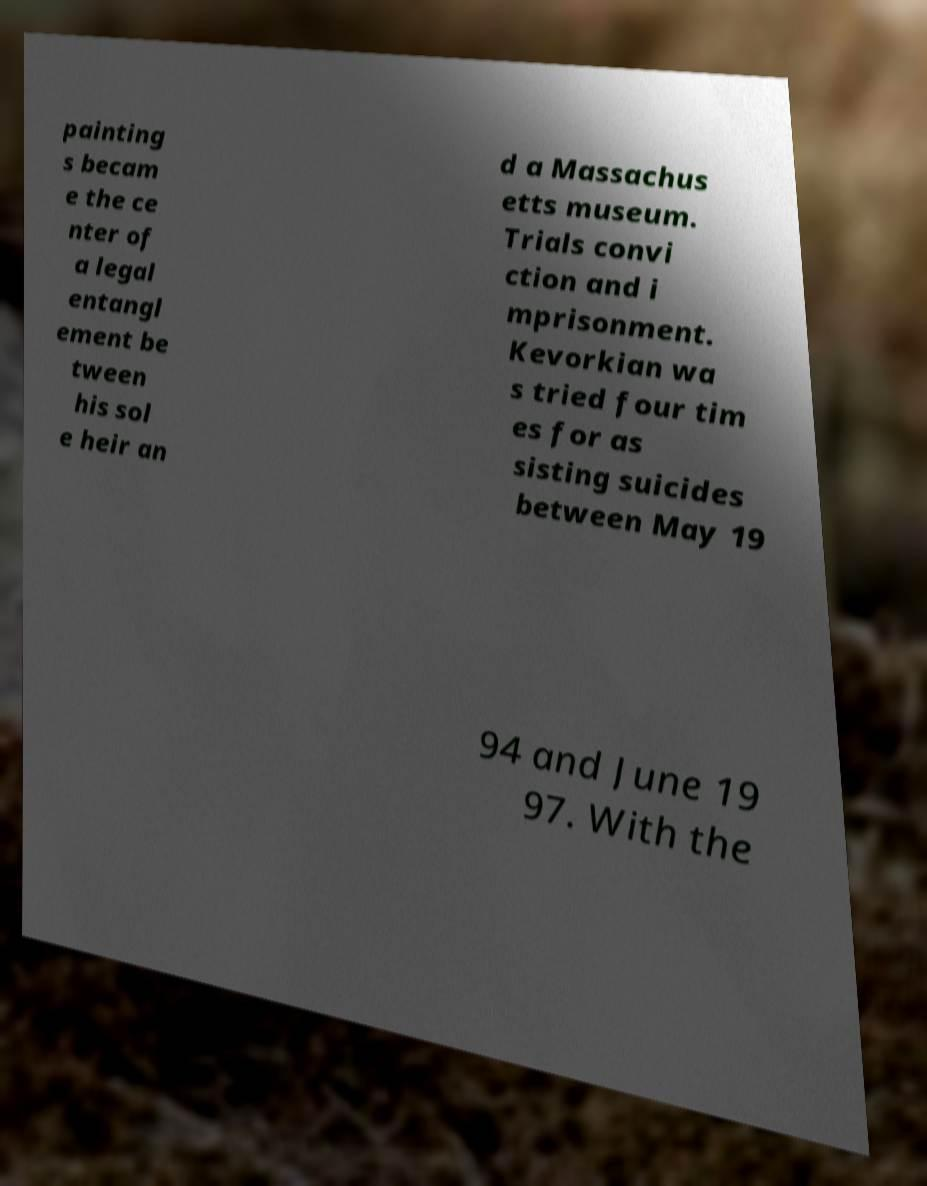There's text embedded in this image that I need extracted. Can you transcribe it verbatim? painting s becam e the ce nter of a legal entangl ement be tween his sol e heir an d a Massachus etts museum. Trials convi ction and i mprisonment. Kevorkian wa s tried four tim es for as sisting suicides between May 19 94 and June 19 97. With the 